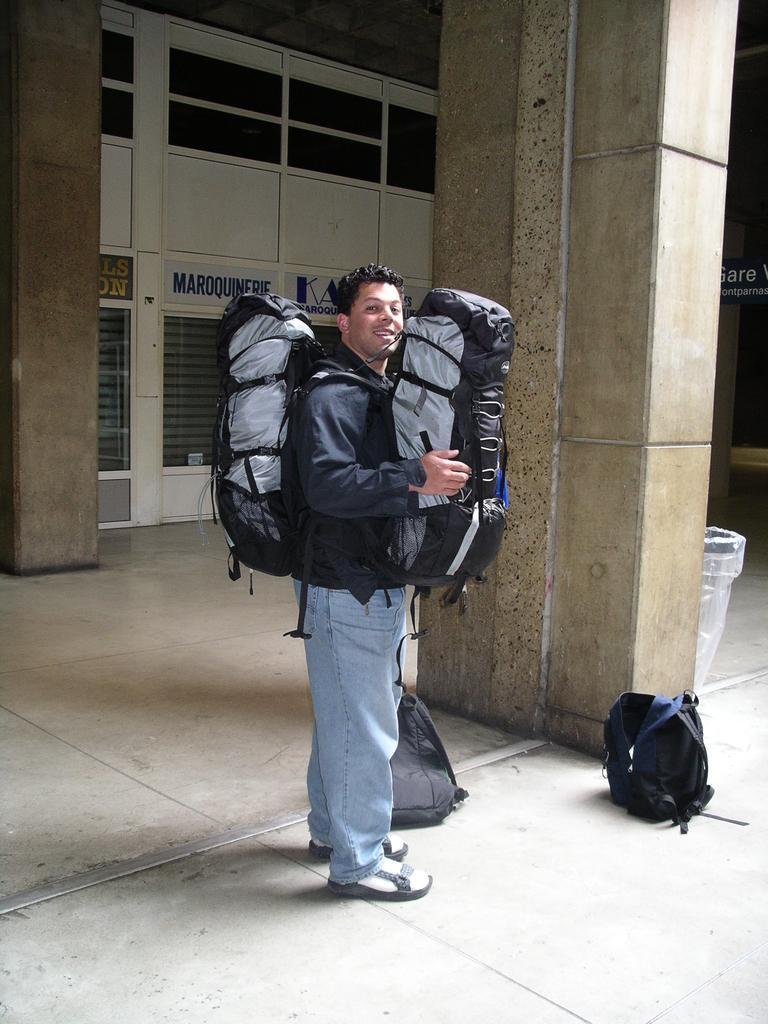Please provide a concise description of this image. Here we can see a man standing in the center. He is wearing a two bags one is into the right side and other one is on the back side. Here we can see there are two bags on the floor and a dustbin on the right side. 